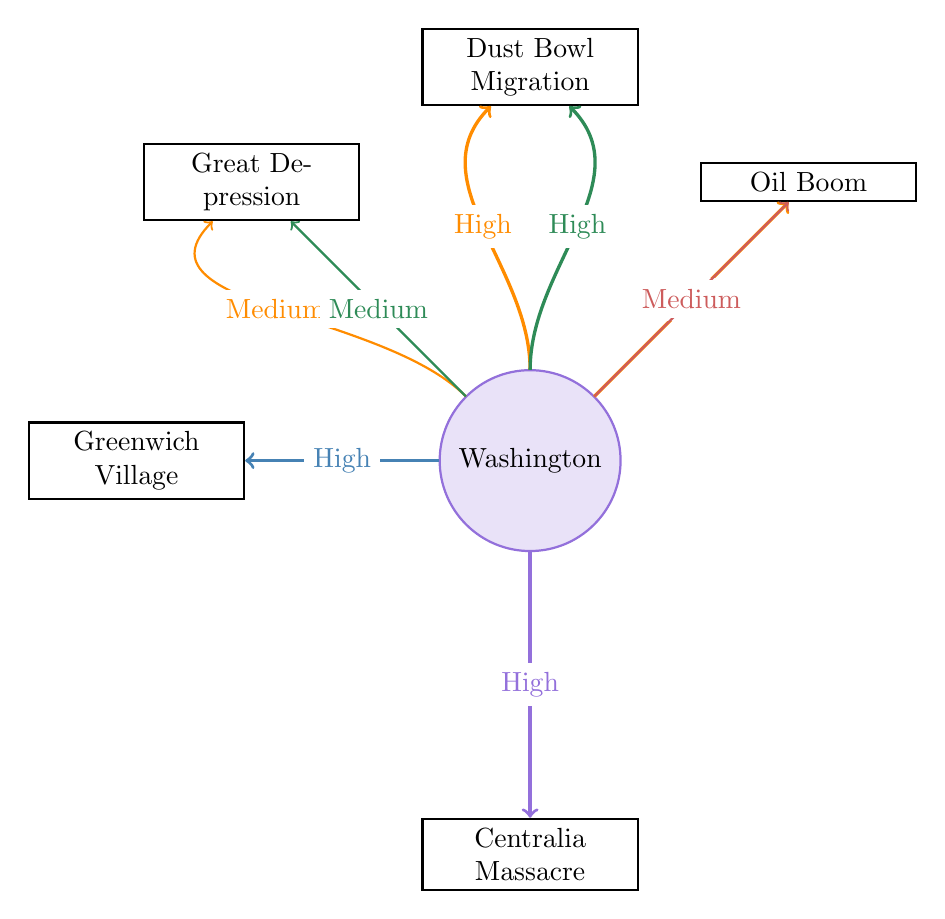What is the influence level of Oklahoma on the Dust Bowl Migration? In the diagram, the arrow from Oklahoma to the Dust Bowl Migration is labeled "High," indicating a strong influence from Oklahoma on this event.
Answer: High How many nodes represent geographical locations in the diagram? The diagram lists five geographic locations: Oklahoma, California, New York, Texas, and Washington. Counting these gives a total of five nodes representing geographic locations.
Answer: 5 Which geographic location has a connection to the Greenwich Village? The only arrow that connects to Greenwich Village comes from New York, showing that this location is closely associated with Greenwich Village.
Answer: New York What influence level does California have on the Great Depression? The arrow from California to the Great Depression is labeled "Medium," indicating a moderate influence from California on the Great Depression.
Answer: Medium Between Oklahoma and Texas, which has a stronger influence on the Oil Boom? The diagram shows a "High" influence from Oklahoma to the Oil Boom and a "Medium" influence from Texas to the Oil Boom. Since "High" is stronger than "Medium," Oklahoma has the stronger influence.
Answer: Oklahoma Which event is significantly connected to Washington in the diagram? The diagram indicates that Washington has a "High" influence on the Centralia Massacre, making this event significantly connected to Washington.
Answer: Centralia Massacre How many total connections (links) are there in the diagram? The diagram lists 8 links total, connecting various nodes of influence, counted directly from the diagram.
Answer: 8 What is the influence level of California on the Dust Bowl Migration? The diagram shows a "High" influence from California to the Dust Bowl Migration, indicating a strong connection.
Answer: High 